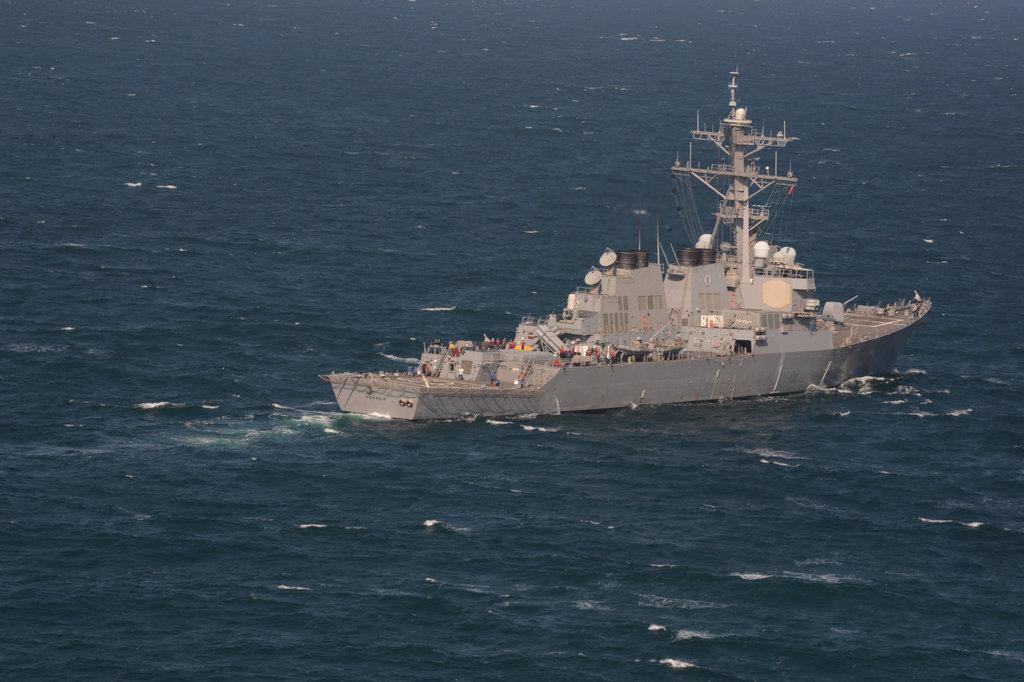How would you summarize this image in a sentence or two? This image is taken outdoors. At the bottom of the image there is a sea with water. In the middle of the image there is a ship on the sea. There are a few people on a ship and there are few poles and wires. 